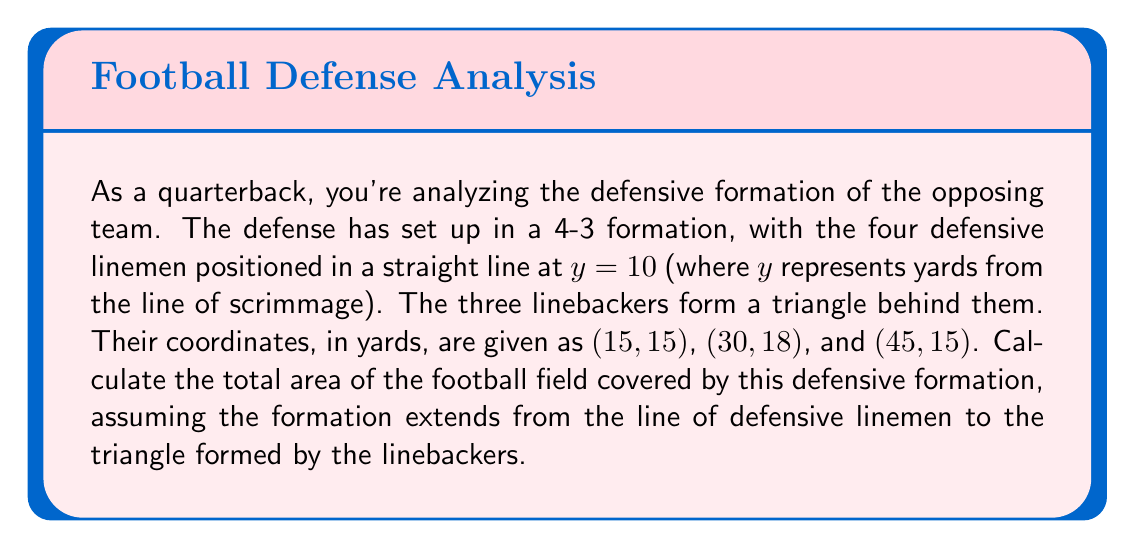Can you answer this question? To solve this problem, we need to calculate the area of a trapezoid formed by the defensive formation. Here's how we can approach it step-by-step:

1) The defensive linemen form the shorter parallel side of the trapezoid at $y = 10$.

2) The linebackers form a triangle, which will be the longer parallel side of the trapezoid.

3) To find the length of this longer side, we need to calculate the distance between the leftmost and rightmost linebackers:
   $\text{Length} = 45 - 15 = 30$ yards

4) The height of the trapezoid is the difference between the $y$-coordinate of the highest linebacker and the $y$-coordinate of the defensive line:
   $\text{Height} = 18 - 10 = 8$ yards

5) The area of a trapezoid is given by the formula:
   $$A = \frac{1}{2}(b_1 + b_2)h$$
   where $b_1$ and $b_2$ are the lengths of the parallel sides and $h$ is the height.

6) In this case:
   $b_1 = 30$ yards (the distance covered by the linebackers)
   $b_2 = 30$ yards (the same distance for the defensive linemen)
   $h = 8$ yards

7) Plugging these values into the formula:
   $$A = \frac{1}{2}(30 + 30) \times 8 = \frac{1}{2} \times 60 \times 8 = 240$$

Therefore, the area covered by the defensive formation is 240 square yards.
Answer: 240 square yards 